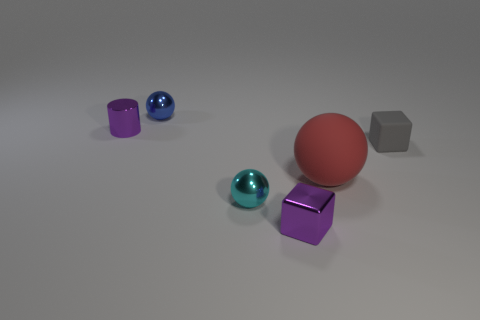Is there anything else that is the same size as the red ball?
Offer a terse response. No. There is a purple object to the left of the tiny metallic block; what is its shape?
Your response must be concise. Cylinder. What number of tiny metallic blocks are the same color as the metal cylinder?
Keep it short and to the point. 1. The tiny rubber object is what color?
Your answer should be compact. Gray. How many big red rubber objects are in front of the shiny ball that is behind the large red ball?
Make the answer very short. 1. Do the cylinder and the purple shiny thing to the right of the small blue object have the same size?
Give a very brief answer. Yes. Is the cyan shiny object the same size as the purple metallic cylinder?
Provide a succinct answer. Yes. Is there a purple metal thing that has the same size as the purple block?
Your answer should be compact. Yes. There is a tiny object that is left of the blue object; what is it made of?
Your answer should be very brief. Metal. There is a block that is the same material as the big red thing; what is its color?
Ensure brevity in your answer.  Gray. 